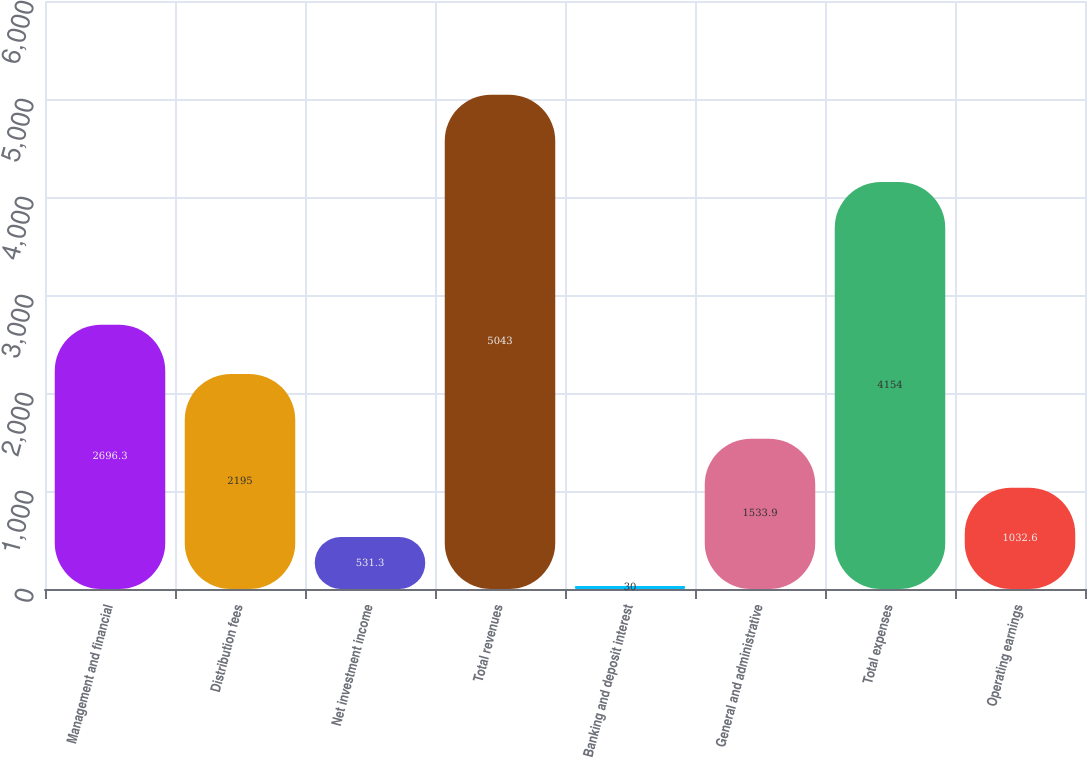<chart> <loc_0><loc_0><loc_500><loc_500><bar_chart><fcel>Management and financial<fcel>Distribution fees<fcel>Net investment income<fcel>Total revenues<fcel>Banking and deposit interest<fcel>General and administrative<fcel>Total expenses<fcel>Operating earnings<nl><fcel>2696.3<fcel>2195<fcel>531.3<fcel>5043<fcel>30<fcel>1533.9<fcel>4154<fcel>1032.6<nl></chart> 